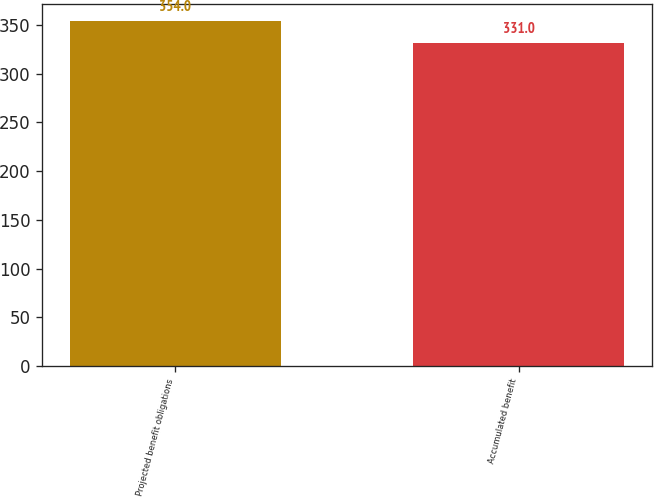Convert chart. <chart><loc_0><loc_0><loc_500><loc_500><bar_chart><fcel>Projected benefit obligations<fcel>Accumulated benefit<nl><fcel>354<fcel>331<nl></chart> 